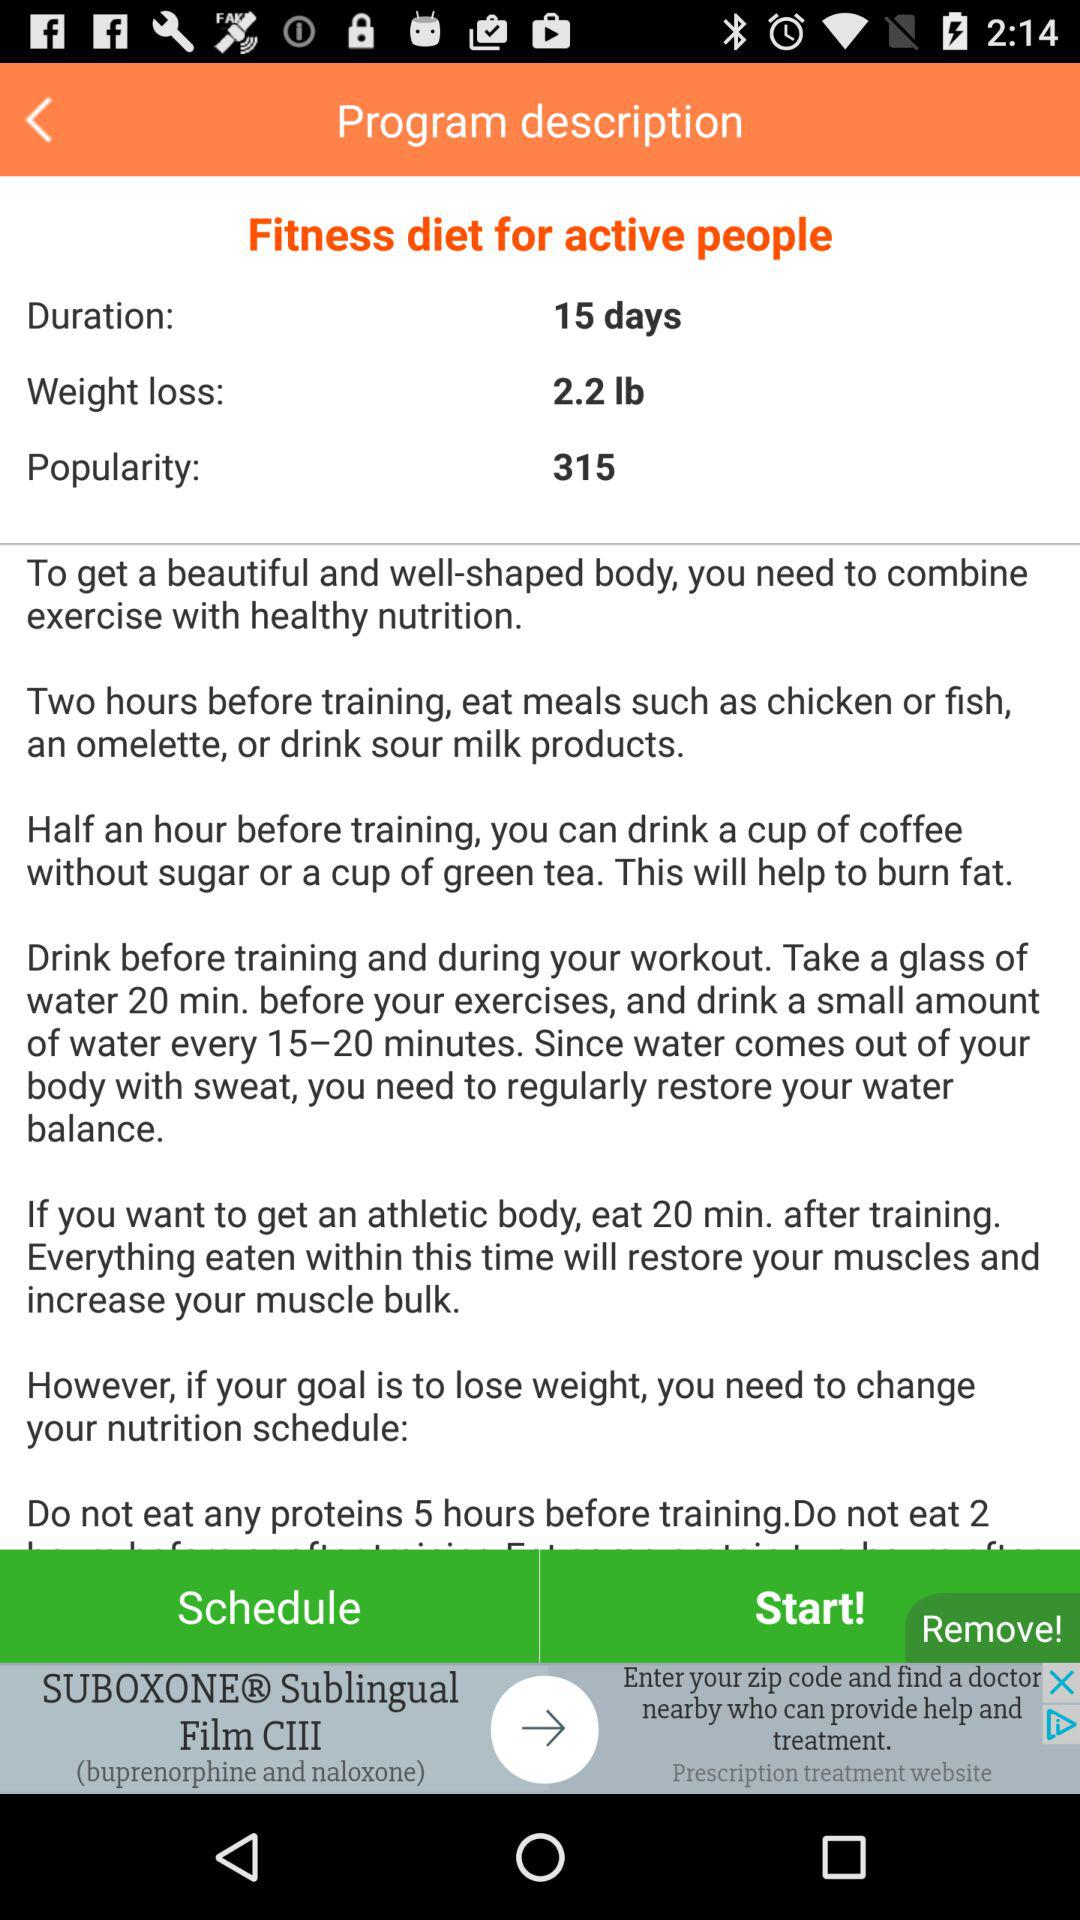What is the popularity? The popularity is 315. 